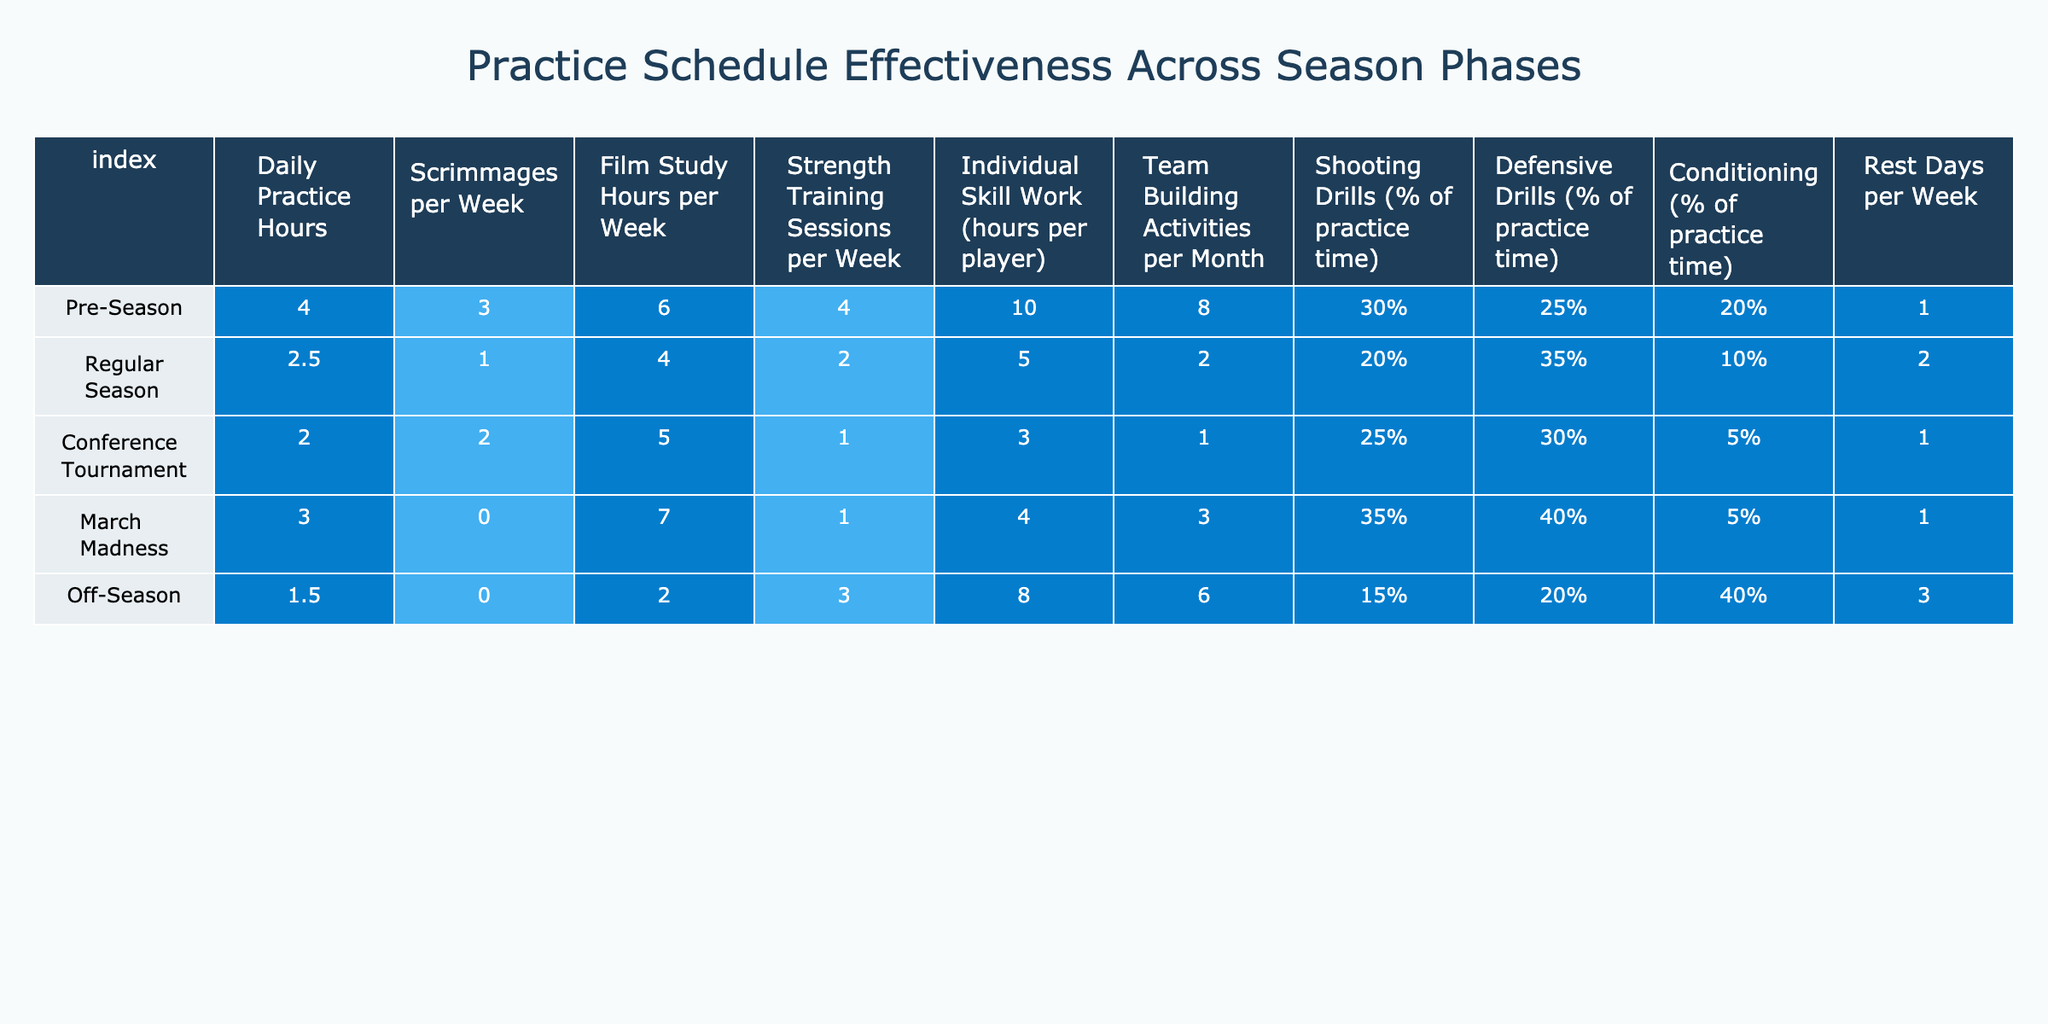What are the daily practice hours during the Pre-Season? Referring to the table, the daily practice hours listed under the Pre-Season phase is 4 hours.
Answer: 4 hours How many scrimmages per week are conducted during the Regular Season? In the table for the Regular Season, the scrimmages per week value is 1.
Answer: 1 What is the total number of film study hours per week across all phases of the season? Summing the film study hours: 6 + 4 + 5 + 7 + 2 = 24 hours total.
Answer: 24 hours During which season phase do players have the least number of strength training sessions per week? The table indicates that during the Conference Tournament phase, there is only 1 strength training session per week, which is the least compared to others.
Answer: Conference Tournament What percentage of practice time is allocated to shooting drills in March Madness? The table states that 35% of practice time during March Madness is dedicated to shooting drills.
Answer: 35% Is there an increase in conditioning practice time from the Off-Season to the Regular Season? The table shows 10% for Regular Season and 40% for Off-Season; therefore, there is a decrease, not an increase.
Answer: No Which phase has the highest individual skill work hours per player, and what is that value? The Pre-Season has the highest individual skill work hours per player at 10 hours.
Answer: 10 hours, Pre-Season Calculate the average number of rest days per week throughout the entire season. Adding rest days: 1 + 2 + 1 + 1 + 3 = 8. There are 5 phases, so average = 8/5 = 1.6 rest days per week.
Answer: 1.6 rest days During which phase is the percentage of time spent on defensive drills the highest? Looking at the table, defensive drills take up 40% of practice time during March Madness, which is the highest percentage.
Answer: March Madness How does the number of team building activities per month change from the Off-Season to the Regular Season? The table shows 6 activities in the Off-Season and 2 during the Regular Season, indicating a decrease of 4 activities.
Answer: Decreased by 4 activities 